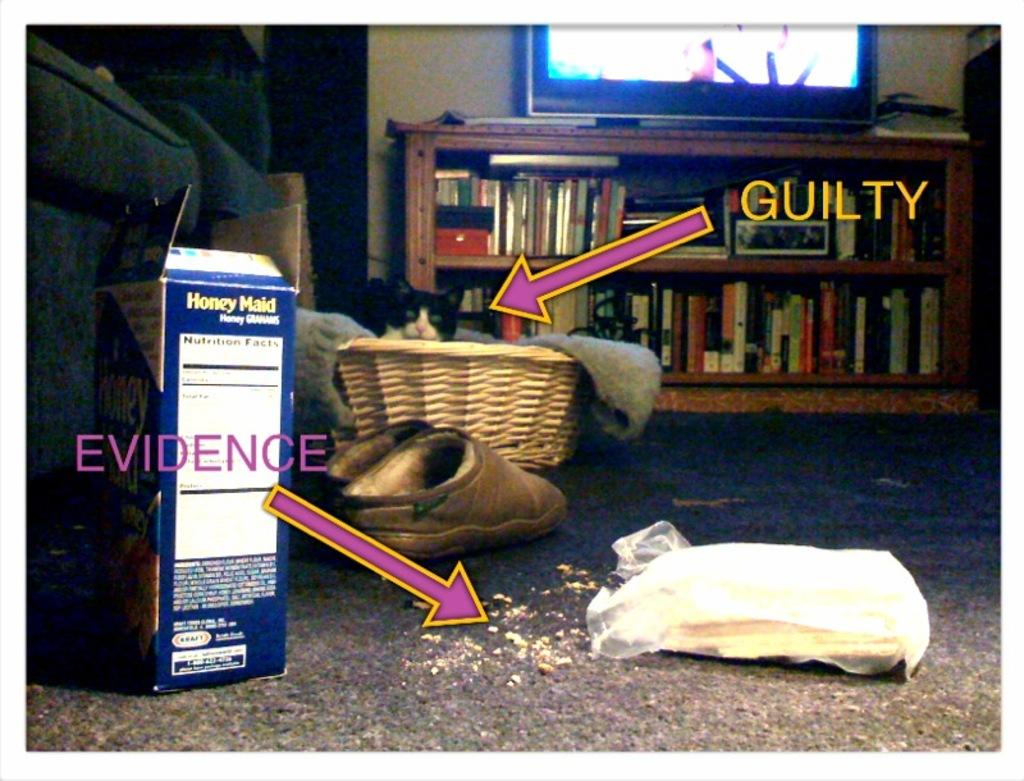What is the main subject in the image? There is a cat in a basket in the image. What other objects can be seen in the image? There are shoes, a cover, arrow symbols, text, books arranged in racks, a television, and a box in the image. Where is the locket located in the image? There is no locket present in the image. What type of boundary can be seen in the image? There is no boundary visible in the image. 